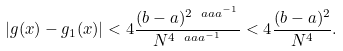<formula> <loc_0><loc_0><loc_500><loc_500>| g ( x ) - g _ { 1 } ( x ) | < 4 \frac { ( b - a ) ^ { 2 \ a a a ^ { - 1 } } } { N ^ { 4 \ a a a ^ { - 1 } } } < 4 \frac { ( b - a ) ^ { 2 } } { N ^ { 4 } } .</formula> 